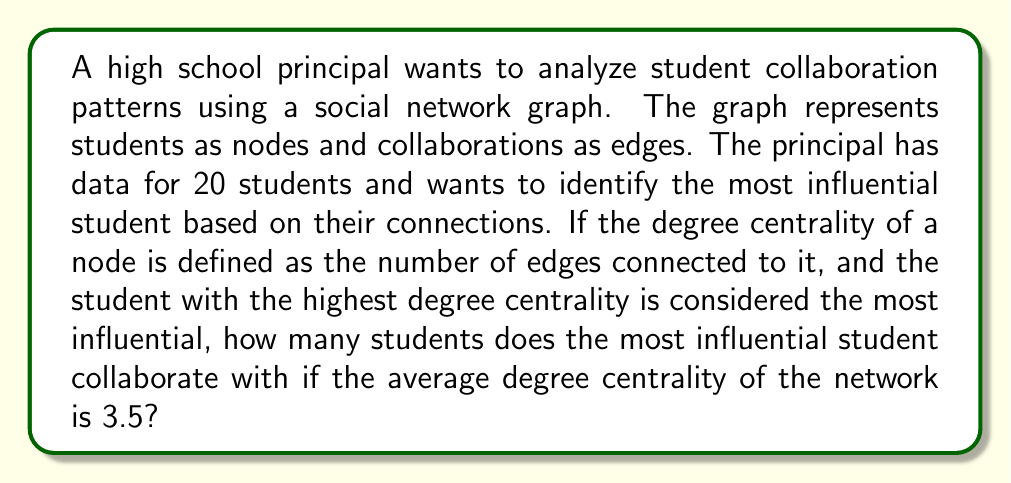Show me your answer to this math problem. Let's approach this step-by-step:

1) First, we need to understand what the average degree centrality means in this context:
   - The average degree centrality is the average number of connections (edges) per node.
   - It's calculated as: $\frac{\text{Total number of edges}}{\text{Number of nodes}}$

2) We're given that:
   - There are 20 students (nodes)
   - The average degree centrality is 3.5

3) Let's calculate the total number of edges:
   $$\text{Total edges} = \frac{\text{Average degree} \times \text{Number of nodes}}{2}$$
   
   We divide by 2 because each edge is counted twice (once for each node it connects).

4) Plugging in the values:
   $$\text{Total edges} = \frac{3.5 \times 20}{2} = 35$$

5) Now, we need to find the highest possible degree for a single node, given this information.

6) The most influential student (the one with the highest degree) must have more connections than the average. Let's call this number of connections $x$.

7) The remaining 19 students must share the remaining $(70 - x)$ edge endpoints (remember, total edges × 2 = 70, as each edge has two endpoints).

8) For the average to be 3.5, we can set up this equation:
   $$\frac{x + (70 - x)}{20} = 3.5$$

9) Simplifying:
   $$\frac{70}{20} = 3.5$$

   This equation is true regardless of $x$, which means our initial assumption was correct.

10) The maximum possible value for $x$ is 19, as a student can at most be connected to all other students.

Therefore, the most influential student collaborates with 19 other students.
Answer: 19 students 